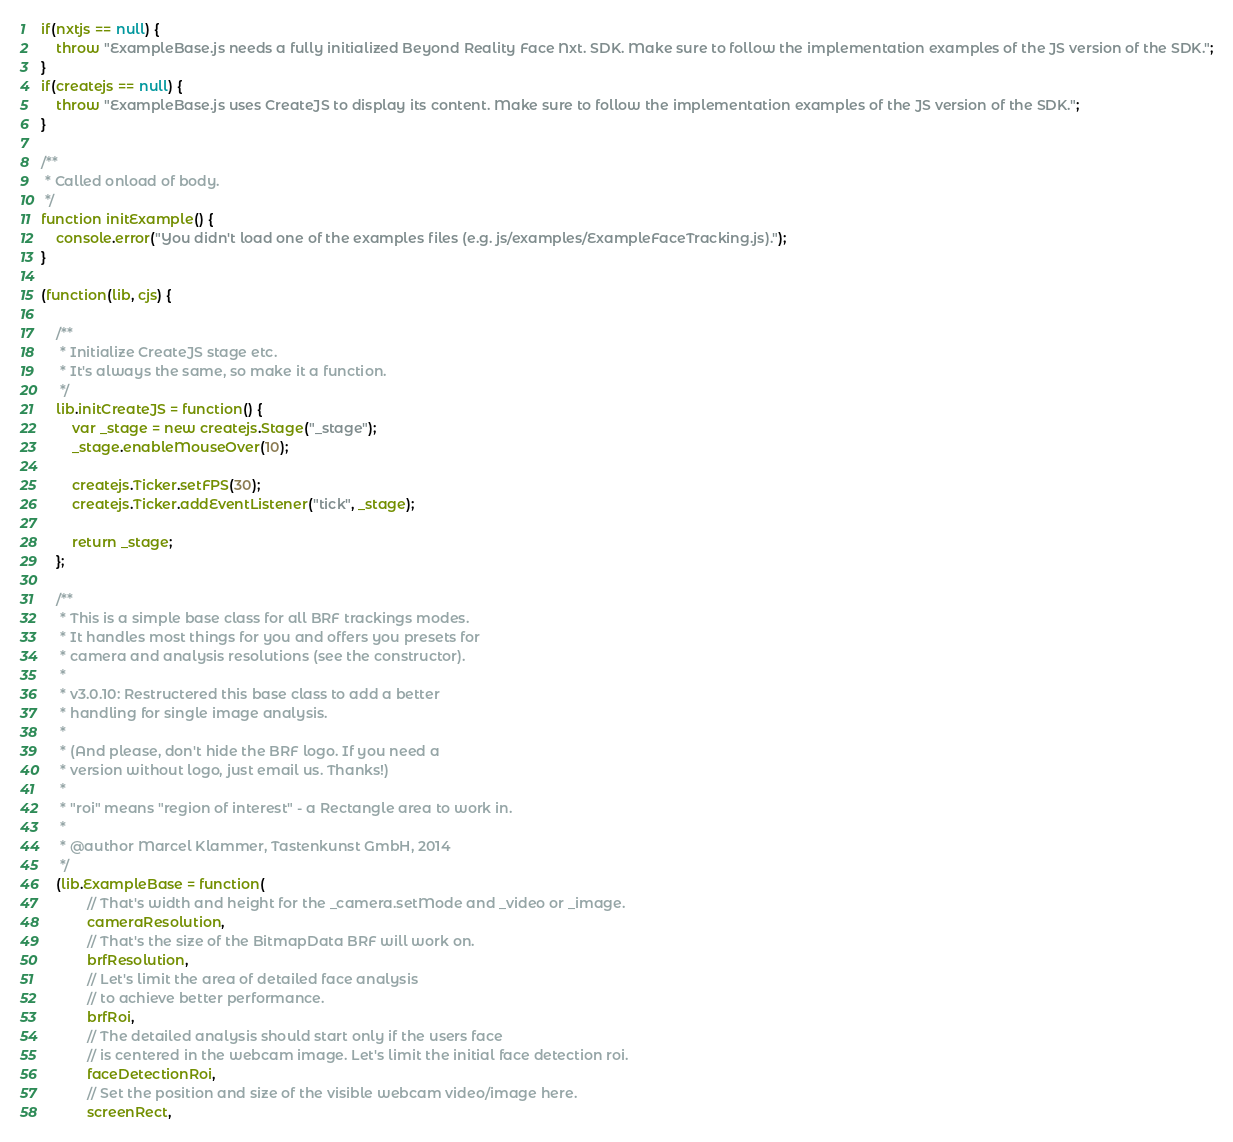Convert code to text. <code><loc_0><loc_0><loc_500><loc_500><_JavaScript_>if(nxtjs == null) {
	throw "ExampleBase.js needs a fully initialized Beyond Reality Face Nxt. SDK. Make sure to follow the implementation examples of the JS version of the SDK.";
}
if(createjs == null) {
	throw "ExampleBase.js uses CreateJS to display its content. Make sure to follow the implementation examples of the JS version of the SDK.";
}

/**
 * Called onload of body.
 */
function initExample() {
	console.error("You didn't load one of the examples files (e.g. js/examples/ExampleFaceTracking.js).");
}

(function(lib, cjs) {

	/**
	 * Initialize CreateJS stage etc.
	 * It's always the same, so make it a function.
	 */
	lib.initCreateJS = function() {
		var _stage = new createjs.Stage("_stage");
		_stage.enableMouseOver(10);
		
		createjs.Ticker.setFPS(30);
		createjs.Ticker.addEventListener("tick", _stage);
		
		return _stage;
	};
	
	/**
	 * This is a simple base class for all BRF trackings modes.
	 * It handles most things for you and offers you presets for 
	 * camera and analysis resolutions (see the constructor).
	 * 
	 * v3.0.10: Restructered this base class to add a better
	 * handling for single image analysis.
	 * 
	 * (And please, don't hide the BRF logo. If you need a 
	 * version without logo, just email us. Thanks!)
	 * 
	 * "roi" means "region of interest" - a Rectangle area to work in.
	 * 
	 * @author Marcel Klammer, Tastenkunst GmbH, 2014
	 */
	(lib.ExampleBase = function(
			// That's width and height for the _camera.setMode and _video or _image.
			cameraResolution,
			// That's the size of the BitmapData BRF will work on.
			brfResolution,
			// Let's limit the area of detailed face analysis
			// to achieve better performance.
			brfRoi,
			// The detailed analysis should start only if the users face
			// is centered in the webcam image. Let's limit the initial face detection roi.
			faceDetectionRoi,
			// Set the position and size of the visible webcam video/image here.
			screenRect,</code> 